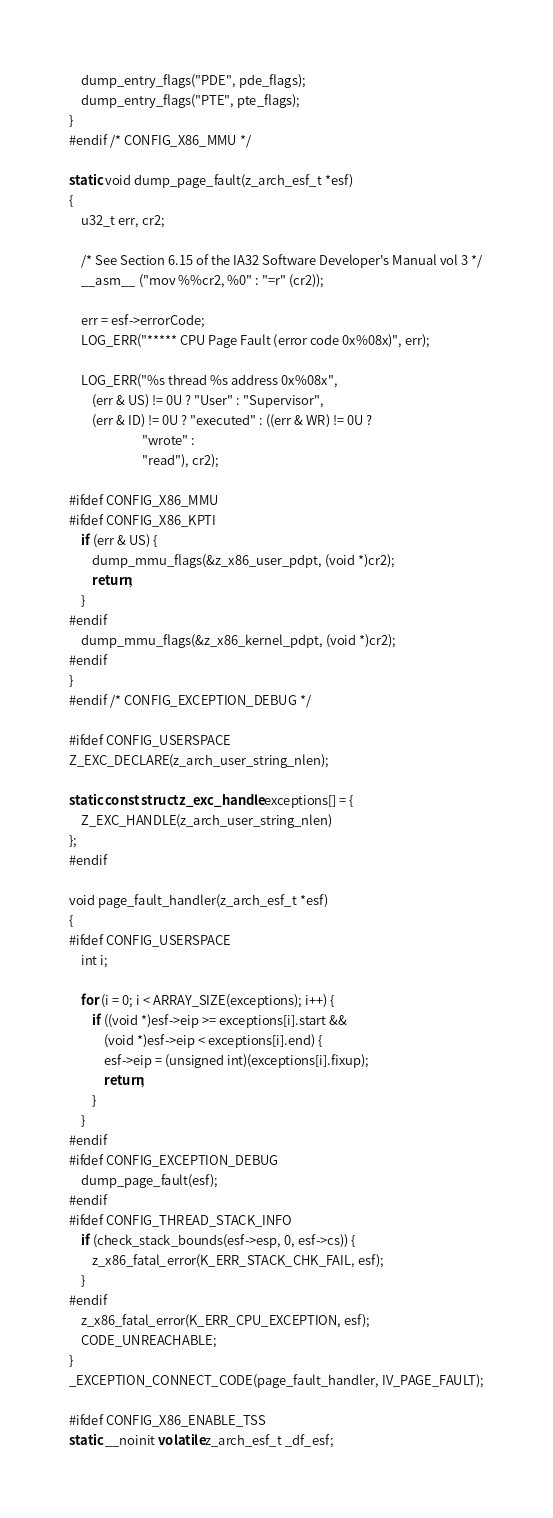<code> <loc_0><loc_0><loc_500><loc_500><_C_>
	dump_entry_flags("PDE", pde_flags);
	dump_entry_flags("PTE", pte_flags);
}
#endif /* CONFIG_X86_MMU */

static void dump_page_fault(z_arch_esf_t *esf)
{
	u32_t err, cr2;

	/* See Section 6.15 of the IA32 Software Developer's Manual vol 3 */
	__asm__ ("mov %%cr2, %0" : "=r" (cr2));

	err = esf->errorCode;
	LOG_ERR("***** CPU Page Fault (error code 0x%08x)", err);

	LOG_ERR("%s thread %s address 0x%08x",
		(err & US) != 0U ? "User" : "Supervisor",
		(err & ID) != 0U ? "executed" : ((err & WR) != 0U ?
						 "wrote" :
						 "read"), cr2);

#ifdef CONFIG_X86_MMU
#ifdef CONFIG_X86_KPTI
	if (err & US) {
		dump_mmu_flags(&z_x86_user_pdpt, (void *)cr2);
		return;
	}
#endif
	dump_mmu_flags(&z_x86_kernel_pdpt, (void *)cr2);
#endif
}
#endif /* CONFIG_EXCEPTION_DEBUG */

#ifdef CONFIG_USERSPACE
Z_EXC_DECLARE(z_arch_user_string_nlen);

static const struct z_exc_handle exceptions[] = {
	Z_EXC_HANDLE(z_arch_user_string_nlen)
};
#endif

void page_fault_handler(z_arch_esf_t *esf)
{
#ifdef CONFIG_USERSPACE
	int i;

	for (i = 0; i < ARRAY_SIZE(exceptions); i++) {
		if ((void *)esf->eip >= exceptions[i].start &&
		    (void *)esf->eip < exceptions[i].end) {
			esf->eip = (unsigned int)(exceptions[i].fixup);
			return;
		}
	}
#endif
#ifdef CONFIG_EXCEPTION_DEBUG
	dump_page_fault(esf);
#endif
#ifdef CONFIG_THREAD_STACK_INFO
	if (check_stack_bounds(esf->esp, 0, esf->cs)) {
		z_x86_fatal_error(K_ERR_STACK_CHK_FAIL, esf);
	}
#endif
	z_x86_fatal_error(K_ERR_CPU_EXCEPTION, esf);
	CODE_UNREACHABLE;
}
_EXCEPTION_CONNECT_CODE(page_fault_handler, IV_PAGE_FAULT);

#ifdef CONFIG_X86_ENABLE_TSS
static __noinit volatile z_arch_esf_t _df_esf;
</code> 